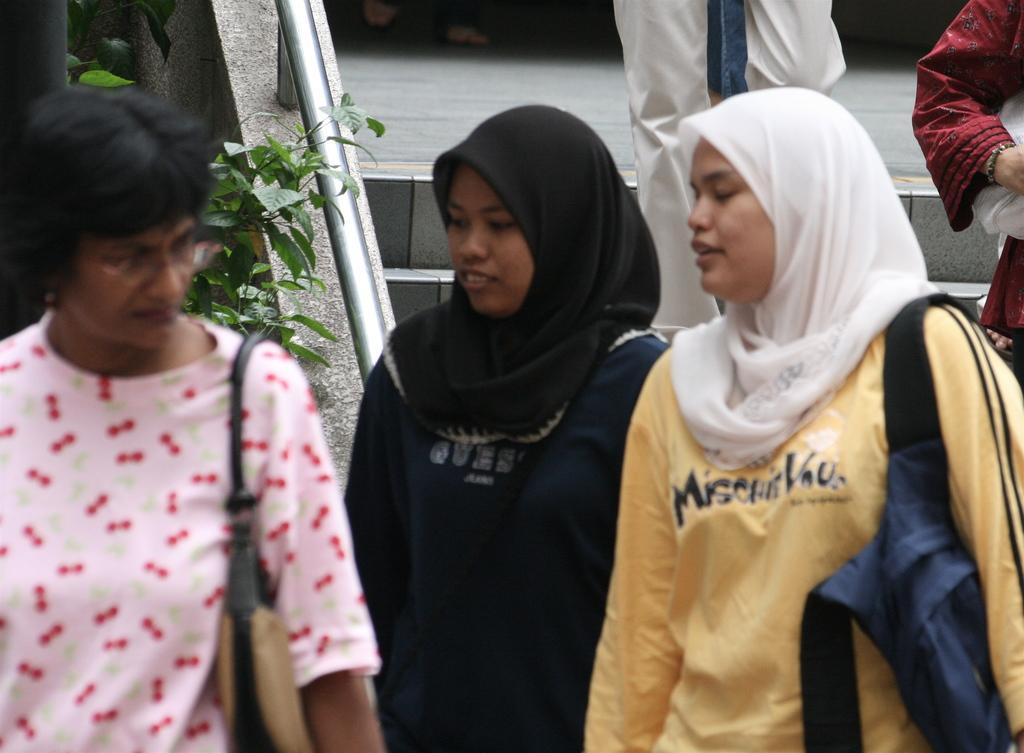How would you summarize this image in a sentence or two? In this image I can see the group of people with different color dresses. I can see two people wearing the bags. In the background I can see the plant and the railing. 